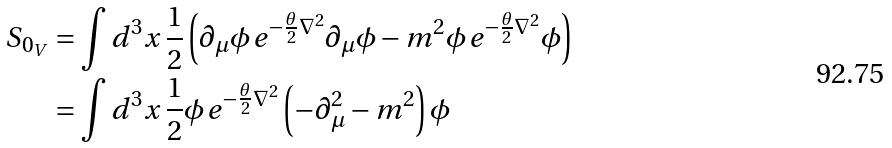<formula> <loc_0><loc_0><loc_500><loc_500>S _ { 0 _ { V } } & = \int d ^ { 3 } x \, \frac { 1 } { 2 } \left ( \partial _ { \mu } \phi \, e ^ { - \frac { \theta } { 2 } \nabla ^ { 2 } } \partial _ { \mu } \phi - m ^ { 2 } \phi \, e ^ { - \frac { \theta } { 2 } \nabla ^ { 2 } } \phi \right ) \\ & = \int d ^ { 3 } x \, \frac { 1 } { 2 } \phi \, e ^ { - \frac { \theta } { 2 } \nabla ^ { 2 } } \left ( - \partial _ { \mu } ^ { 2 } - m ^ { 2 } \right ) \phi</formula> 